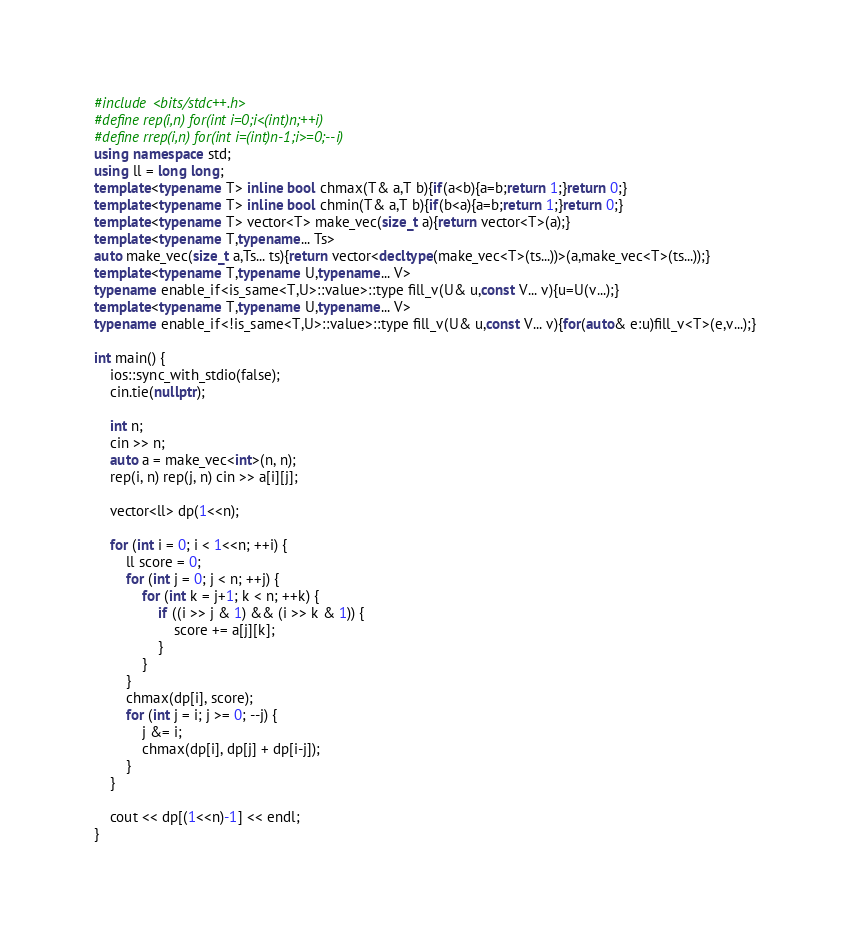<code> <loc_0><loc_0><loc_500><loc_500><_C++_>#include <bits/stdc++.h>
#define rep(i,n) for(int i=0;i<(int)n;++i)
#define rrep(i,n) for(int i=(int)n-1;i>=0;--i)
using namespace std;
using ll = long long;
template<typename T> inline bool chmax(T& a,T b){if(a<b){a=b;return 1;}return 0;}
template<typename T> inline bool chmin(T& a,T b){if(b<a){a=b;return 1;}return 0;}
template<typename T> vector<T> make_vec(size_t a){return vector<T>(a);}
template<typename T,typename... Ts>
auto make_vec(size_t a,Ts... ts){return vector<decltype(make_vec<T>(ts...))>(a,make_vec<T>(ts...));}
template<typename T,typename U,typename... V>
typename enable_if<is_same<T,U>::value>::type fill_v(U& u,const V... v){u=U(v...);}
template<typename T,typename U,typename... V>
typename enable_if<!is_same<T,U>::value>::type fill_v(U& u,const V... v){for(auto& e:u)fill_v<T>(e,v...);}

int main() {
    ios::sync_with_stdio(false);
    cin.tie(nullptr);

    int n;
    cin >> n;
    auto a = make_vec<int>(n, n);
    rep(i, n) rep(j, n) cin >> a[i][j];

    vector<ll> dp(1<<n);

    for (int i = 0; i < 1<<n; ++i) {
        ll score = 0;
        for (int j = 0; j < n; ++j) {
            for (int k = j+1; k < n; ++k) {
                if ((i >> j & 1) && (i >> k & 1)) {
                    score += a[j][k];
                }
            }
        }
        chmax(dp[i], score);
        for (int j = i; j >= 0; --j) {
            j &= i;
            chmax(dp[i], dp[j] + dp[i-j]);
        }
    }

    cout << dp[(1<<n)-1] << endl;
}
</code> 